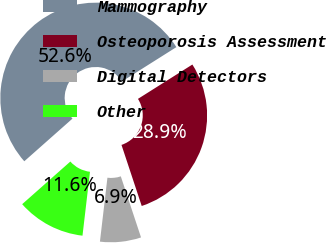Convert chart. <chart><loc_0><loc_0><loc_500><loc_500><pie_chart><fcel>Mammography<fcel>Osteoporosis Assessment<fcel>Digital Detectors<fcel>Other<nl><fcel>52.57%<fcel>28.87%<fcel>6.95%<fcel>11.61%<nl></chart> 